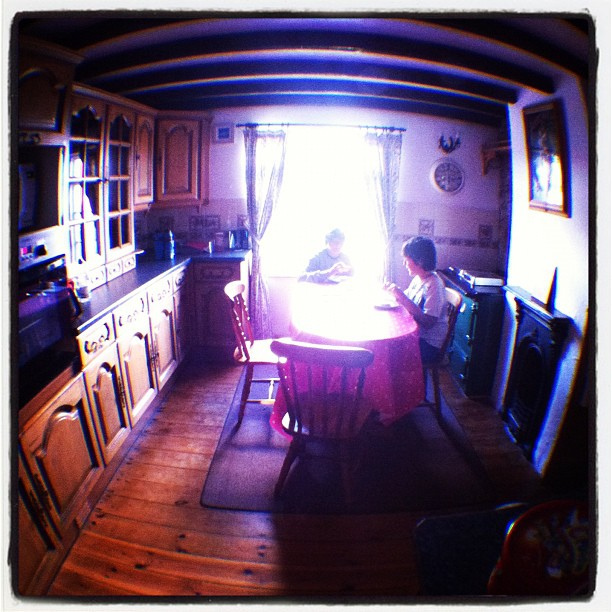What time of day does it appear to be in this image? Given the angle and intensity of the natural light pouring in through the window, it appears to be either early morning or late afternoon, times known for their softer, more golden light quality. 